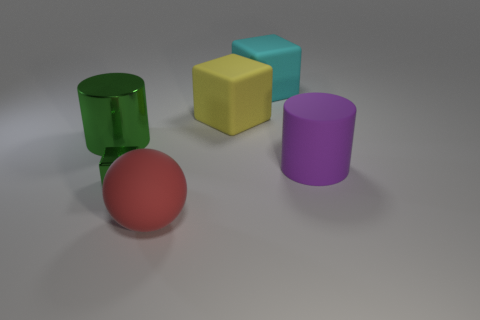Subtract all yellow spheres. Subtract all yellow blocks. How many spheres are left? 1 Add 4 large purple metal blocks. How many objects exist? 10 Subtract all balls. How many objects are left? 5 Add 2 balls. How many balls are left? 3 Add 2 purple rubber objects. How many purple rubber objects exist? 3 Subtract 0 red cubes. How many objects are left? 6 Subtract all small cyan balls. Subtract all purple cylinders. How many objects are left? 5 